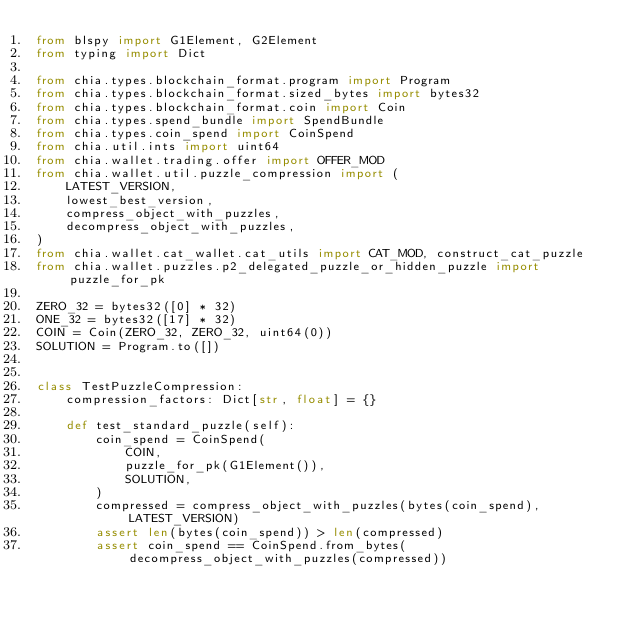Convert code to text. <code><loc_0><loc_0><loc_500><loc_500><_Python_>from blspy import G1Element, G2Element
from typing import Dict

from chia.types.blockchain_format.program import Program
from chia.types.blockchain_format.sized_bytes import bytes32
from chia.types.blockchain_format.coin import Coin
from chia.types.spend_bundle import SpendBundle
from chia.types.coin_spend import CoinSpend
from chia.util.ints import uint64
from chia.wallet.trading.offer import OFFER_MOD
from chia.wallet.util.puzzle_compression import (
    LATEST_VERSION,
    lowest_best_version,
    compress_object_with_puzzles,
    decompress_object_with_puzzles,
)
from chia.wallet.cat_wallet.cat_utils import CAT_MOD, construct_cat_puzzle
from chia.wallet.puzzles.p2_delegated_puzzle_or_hidden_puzzle import puzzle_for_pk

ZERO_32 = bytes32([0] * 32)
ONE_32 = bytes32([17] * 32)
COIN = Coin(ZERO_32, ZERO_32, uint64(0))
SOLUTION = Program.to([])


class TestPuzzleCompression:
    compression_factors: Dict[str, float] = {}

    def test_standard_puzzle(self):
        coin_spend = CoinSpend(
            COIN,
            puzzle_for_pk(G1Element()),
            SOLUTION,
        )
        compressed = compress_object_with_puzzles(bytes(coin_spend), LATEST_VERSION)
        assert len(bytes(coin_spend)) > len(compressed)
        assert coin_spend == CoinSpend.from_bytes(decompress_object_with_puzzles(compressed))</code> 